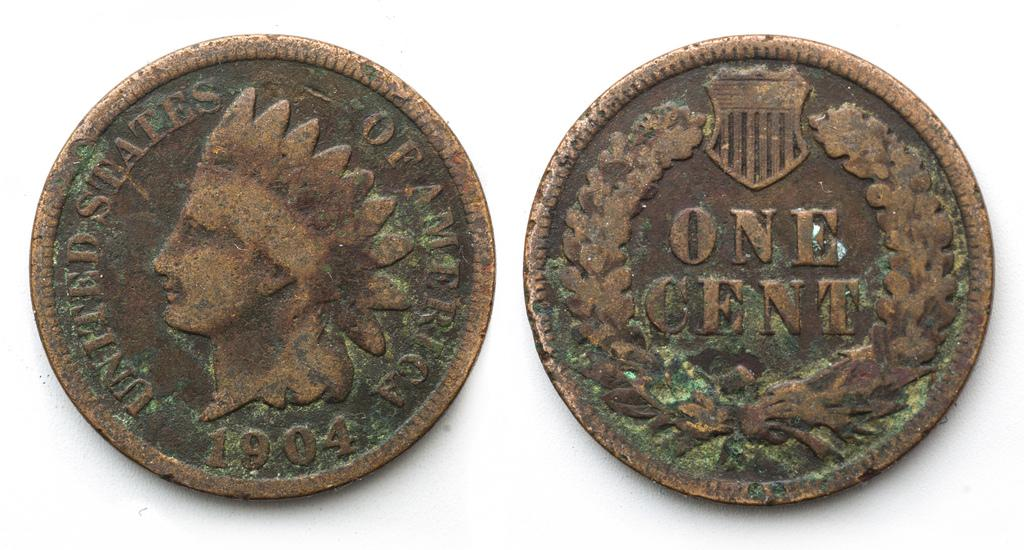<image>
Create a compact narrative representing the image presented. The front and backside of a penny that is from the year 1904. 